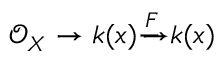<formula> <loc_0><loc_0><loc_500><loc_500>{ \mathcal { O } } _ { X } \to k ( x ) { \xrightarrow { { F } } } k ( x )</formula> 